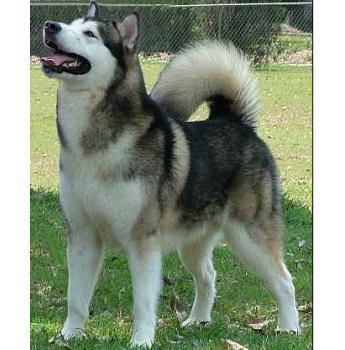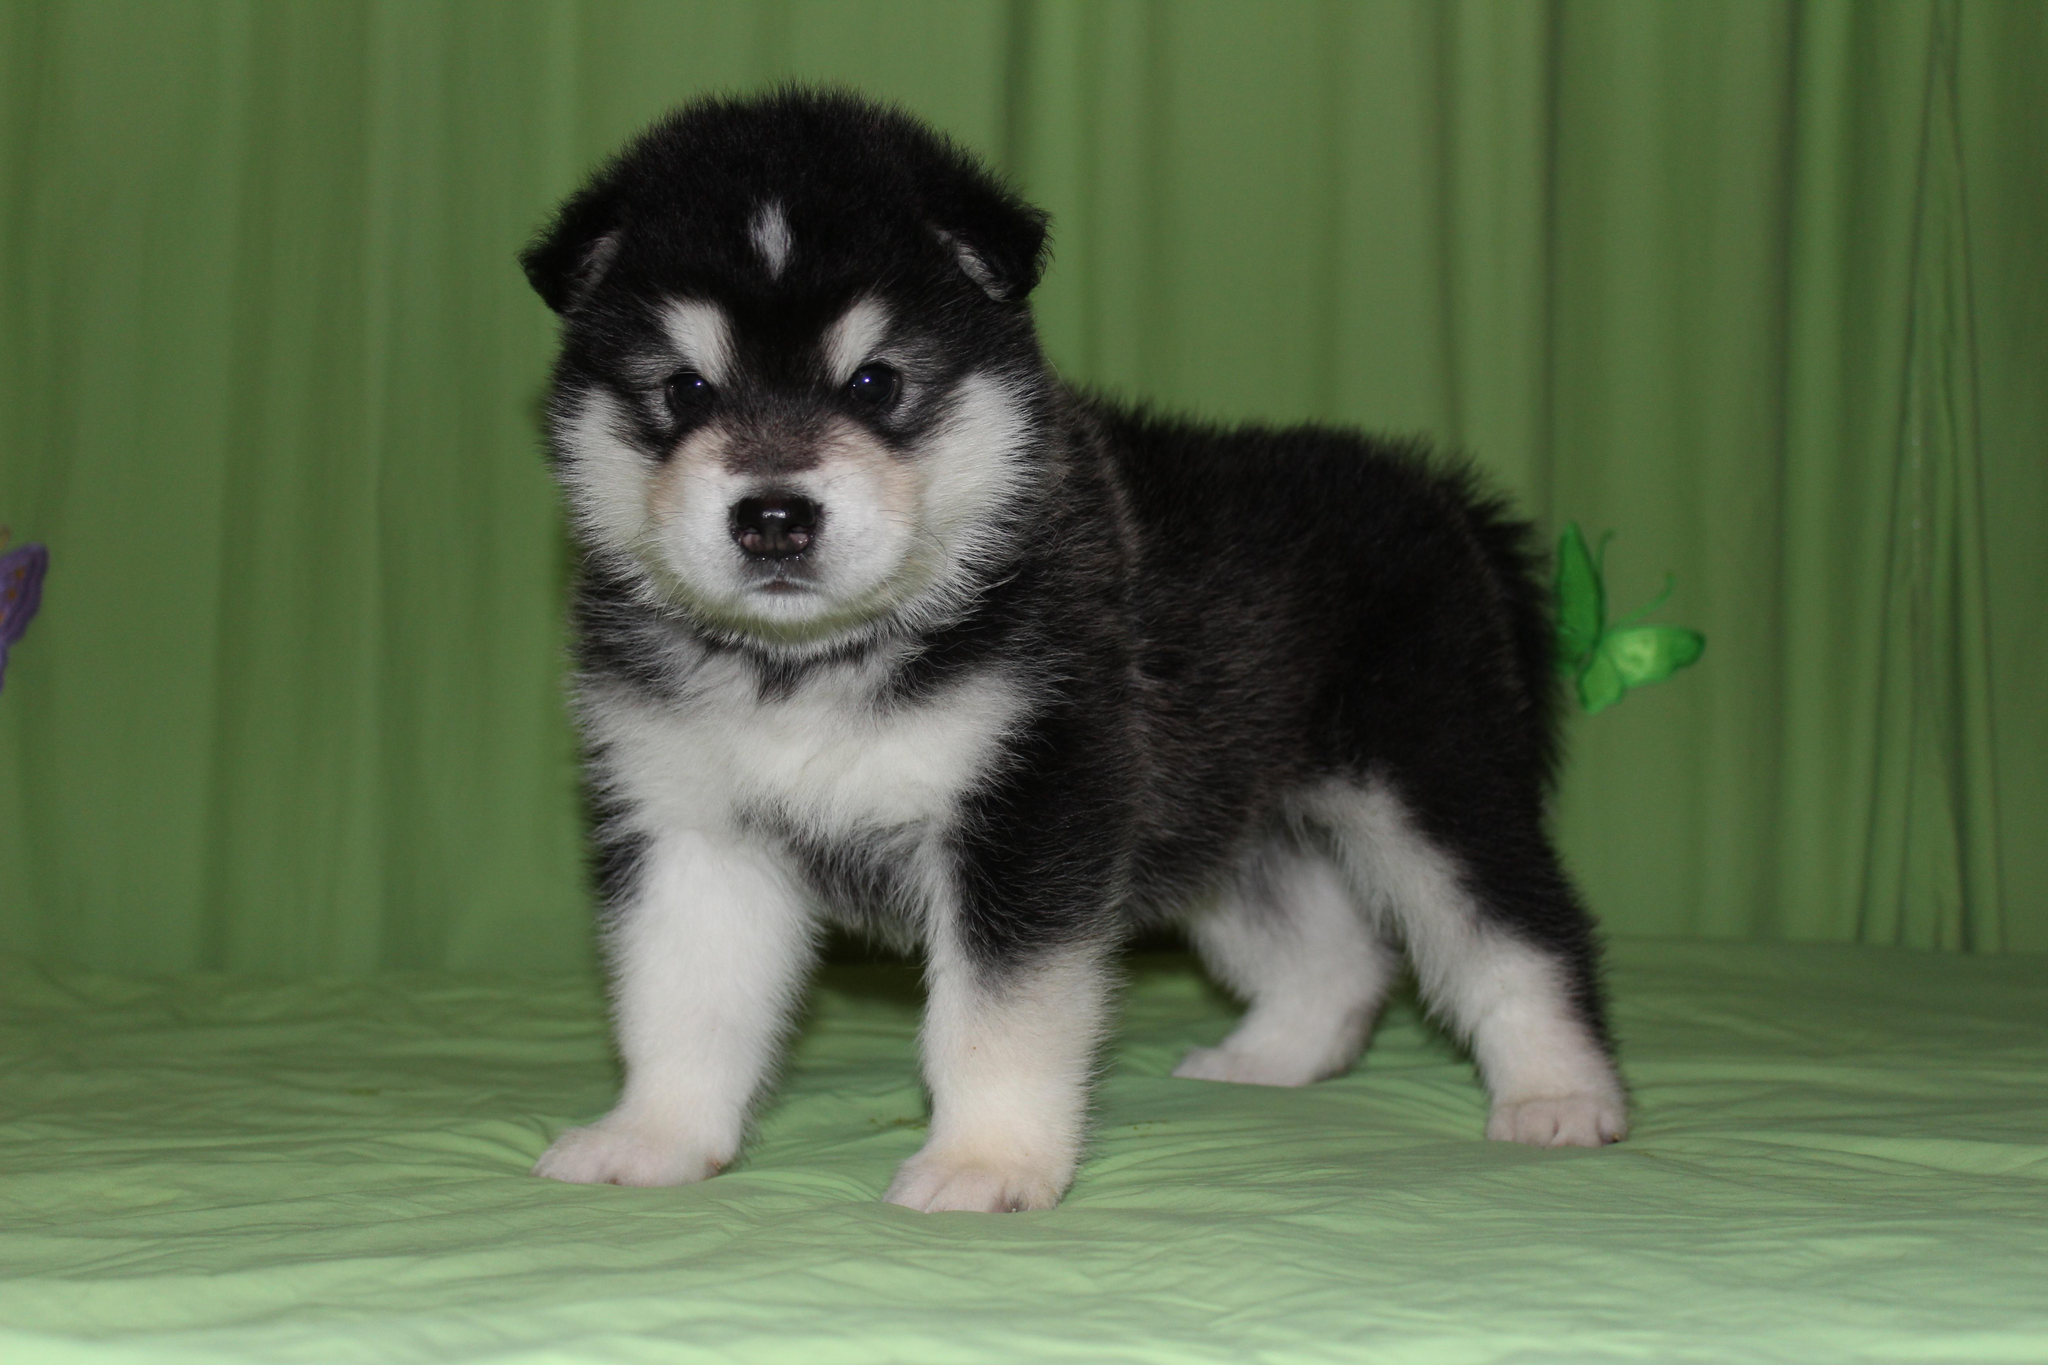The first image is the image on the left, the second image is the image on the right. Given the left and right images, does the statement "Both dogs have their tongues out." hold true? Answer yes or no. No. The first image is the image on the left, the second image is the image on the right. Analyze the images presented: Is the assertion "The dog in the image on the left has its tail up and curled over its back." valid? Answer yes or no. Yes. 